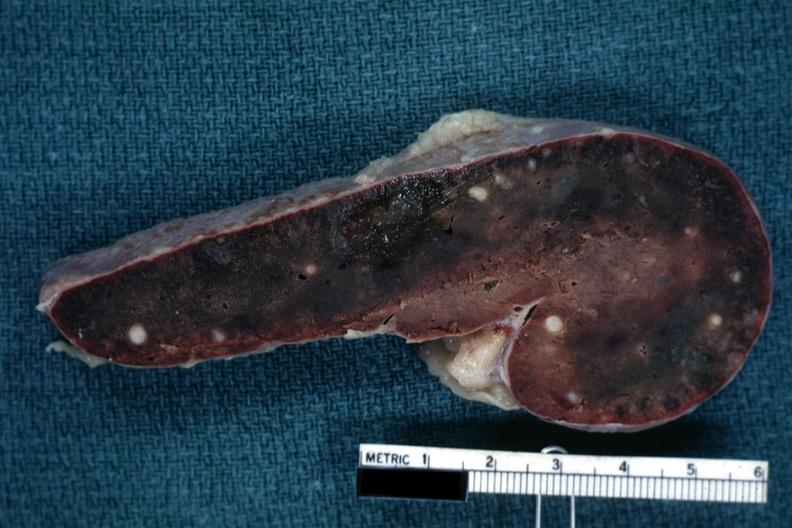where is this part in?
Answer the question using a single word or phrase. Spleen 